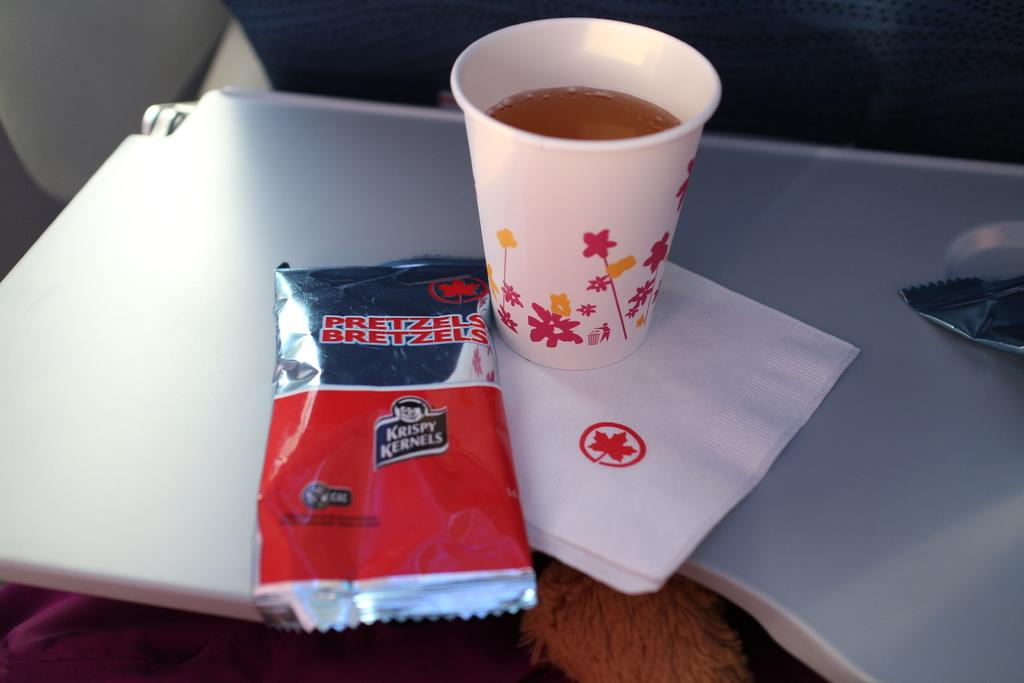What objects are in the foreground of the image? There is a sachet, a tissue, and a cup on a table in the foreground of the image. Are there any other sachets visible in the image? Yes, there is another sachet on the right side of the image. What type of button is being used to hold the camp together in the image? There is no camp or button present in the image. How many bricks are visible in the image? There are no bricks visible in the image. 